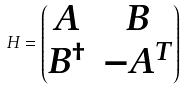<formula> <loc_0><loc_0><loc_500><loc_500>H = \begin{pmatrix} A & B \\ B ^ { \dagger } & - A ^ { T } \end{pmatrix}</formula> 